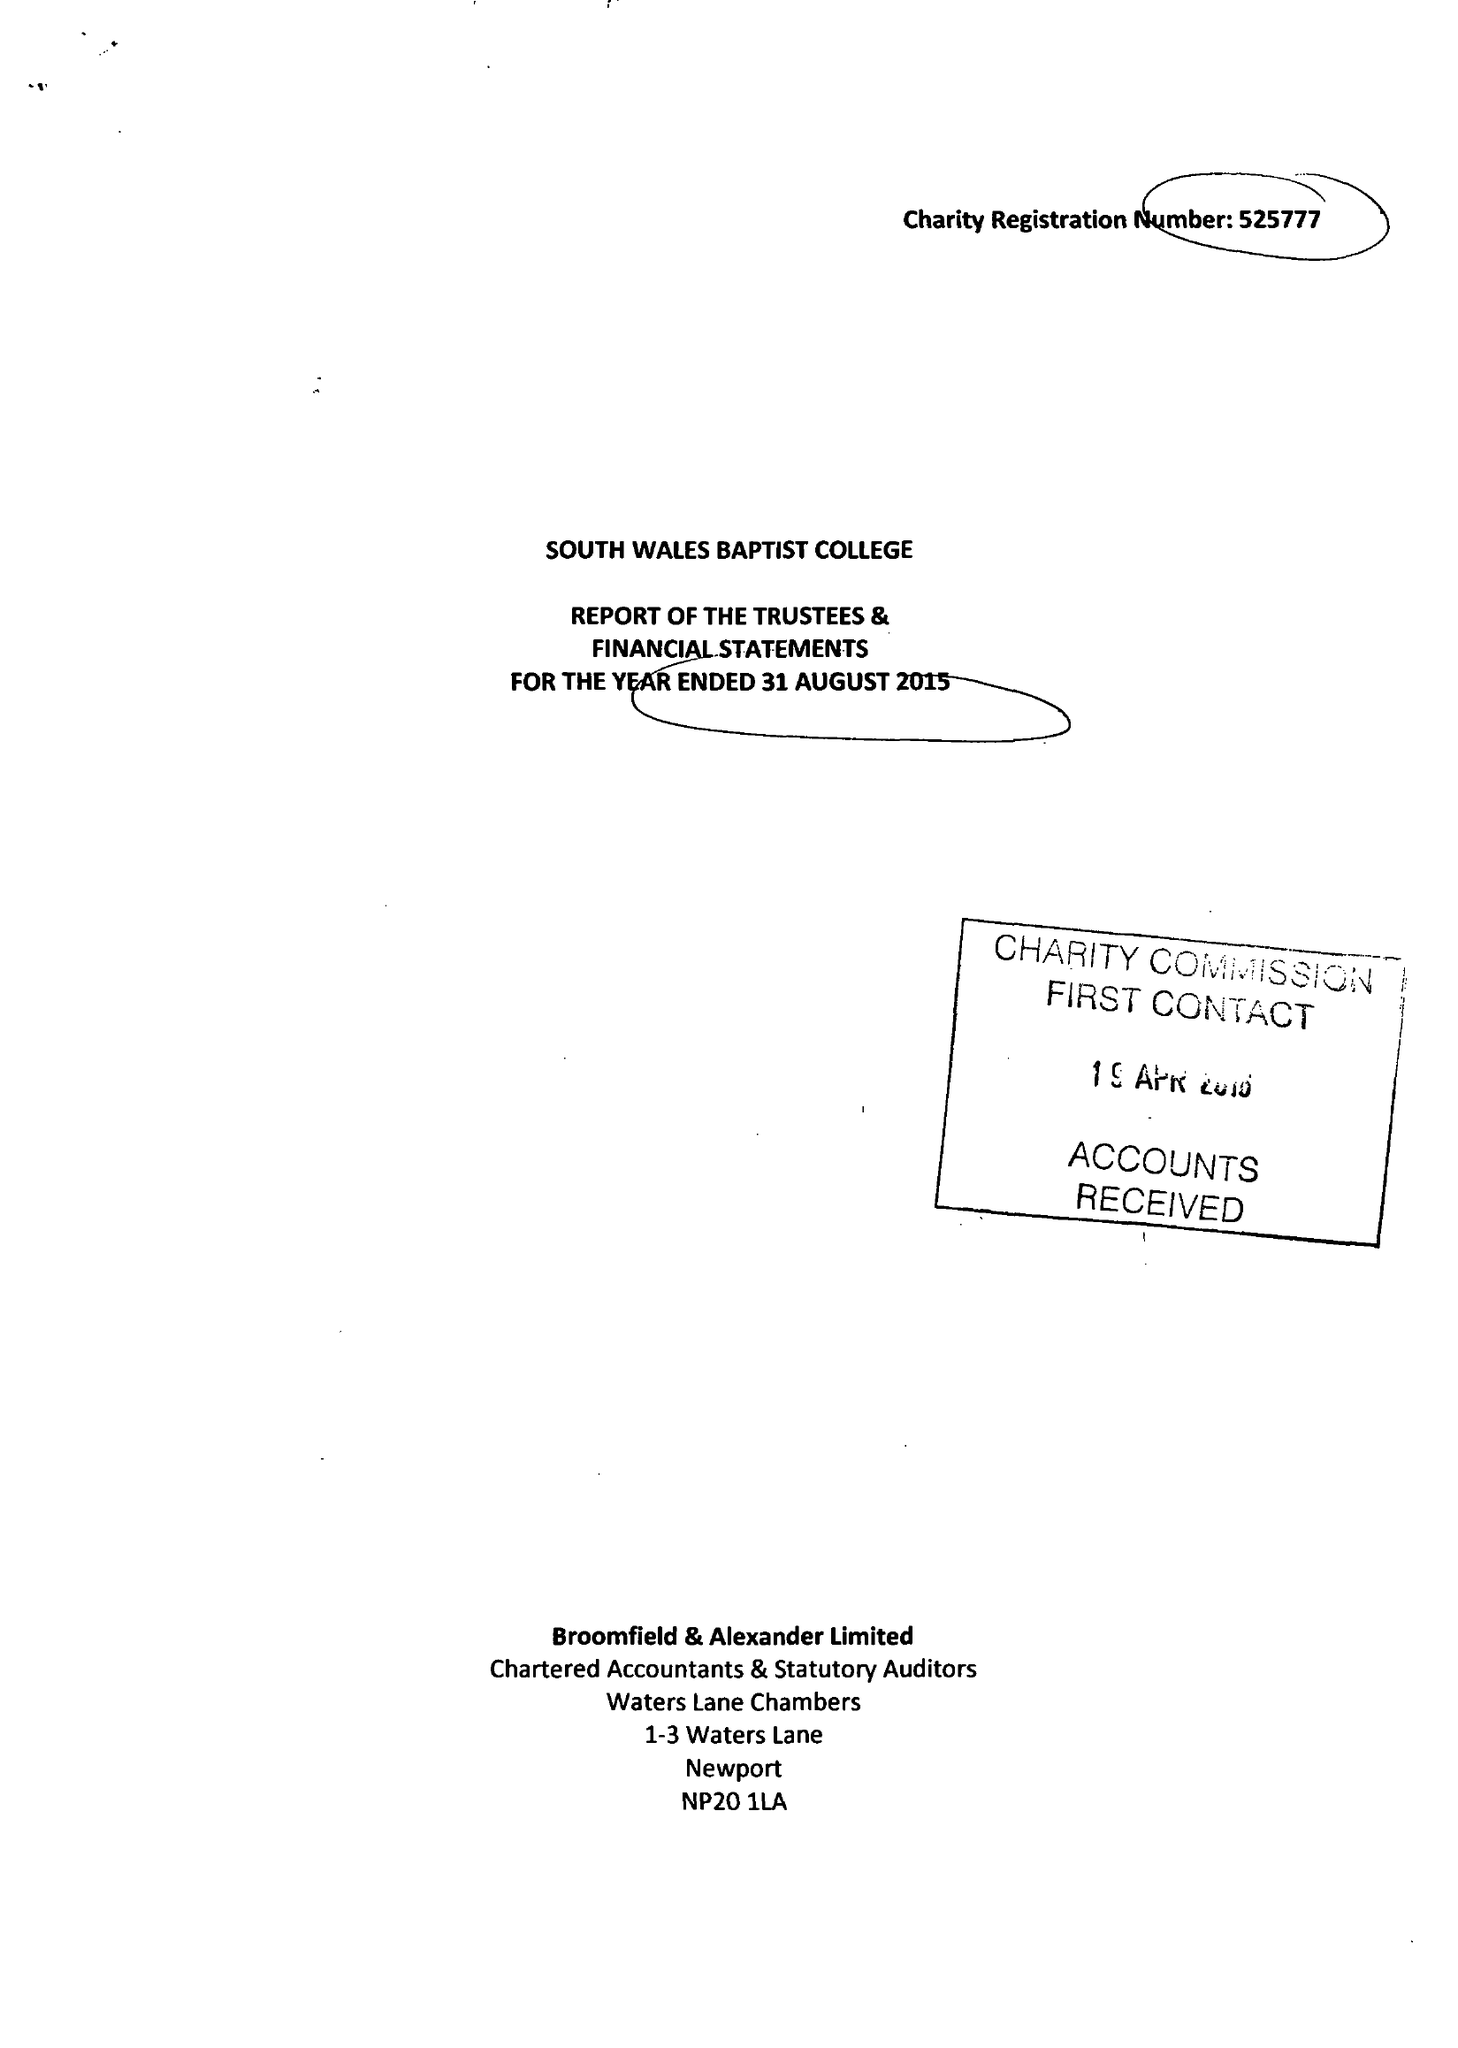What is the value for the address__postcode?
Answer the question using a single word or phrase. CF24 3UR 